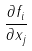<formula> <loc_0><loc_0><loc_500><loc_500>\frac { \partial f _ { i } } { \partial x _ { j } }</formula> 